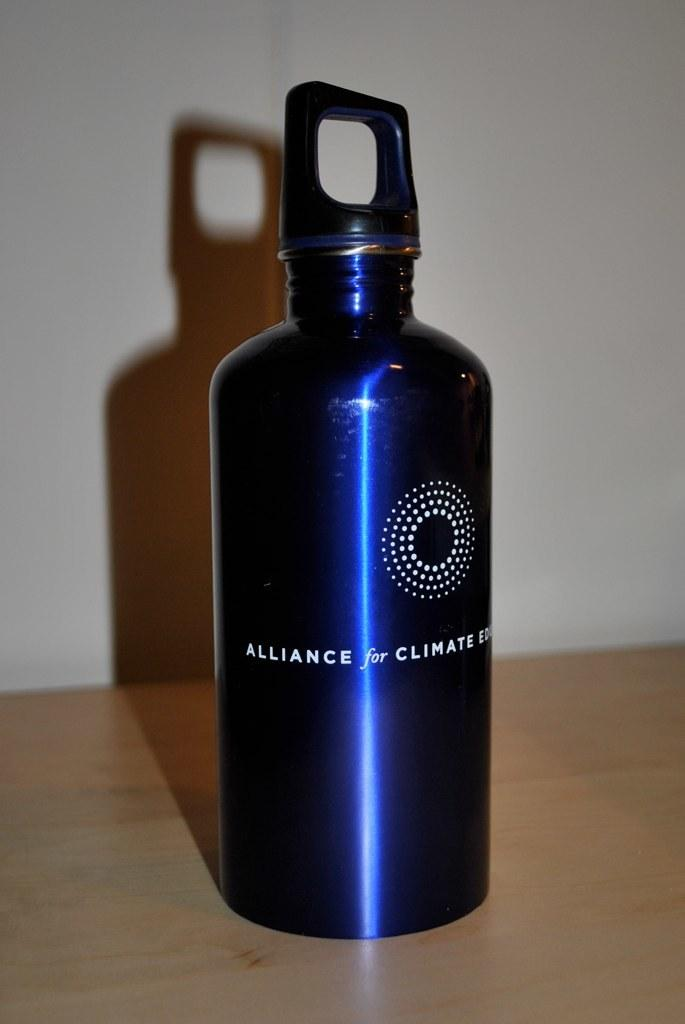<image>
Write a terse but informative summary of the picture. A blue metal water bottle that says Alliance for Climate and has a bunch of dots in a circle on it. 